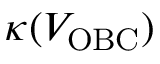<formula> <loc_0><loc_0><loc_500><loc_500>\kappa ( V _ { O B C } )</formula> 